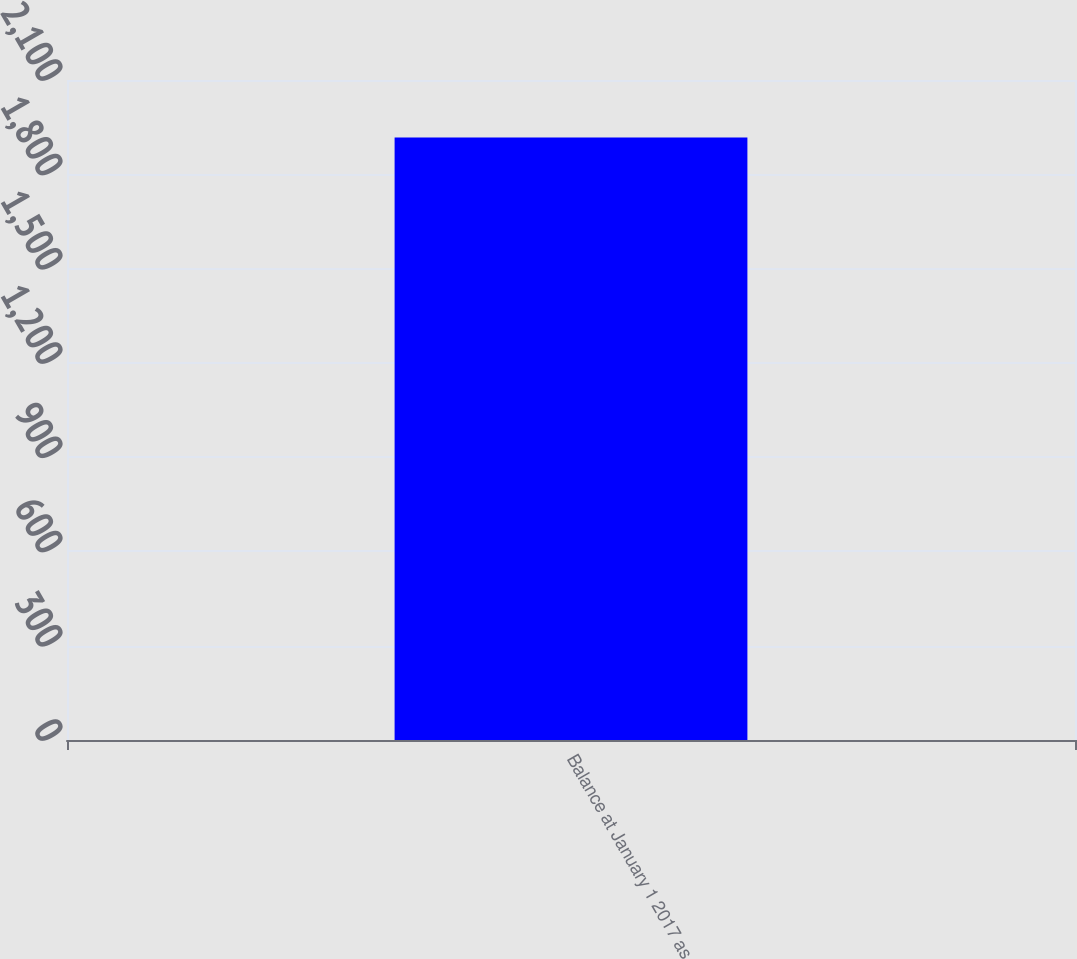Convert chart to OTSL. <chart><loc_0><loc_0><loc_500><loc_500><bar_chart><fcel>Balance at January 1 2017 as<nl><fcel>1917<nl></chart> 